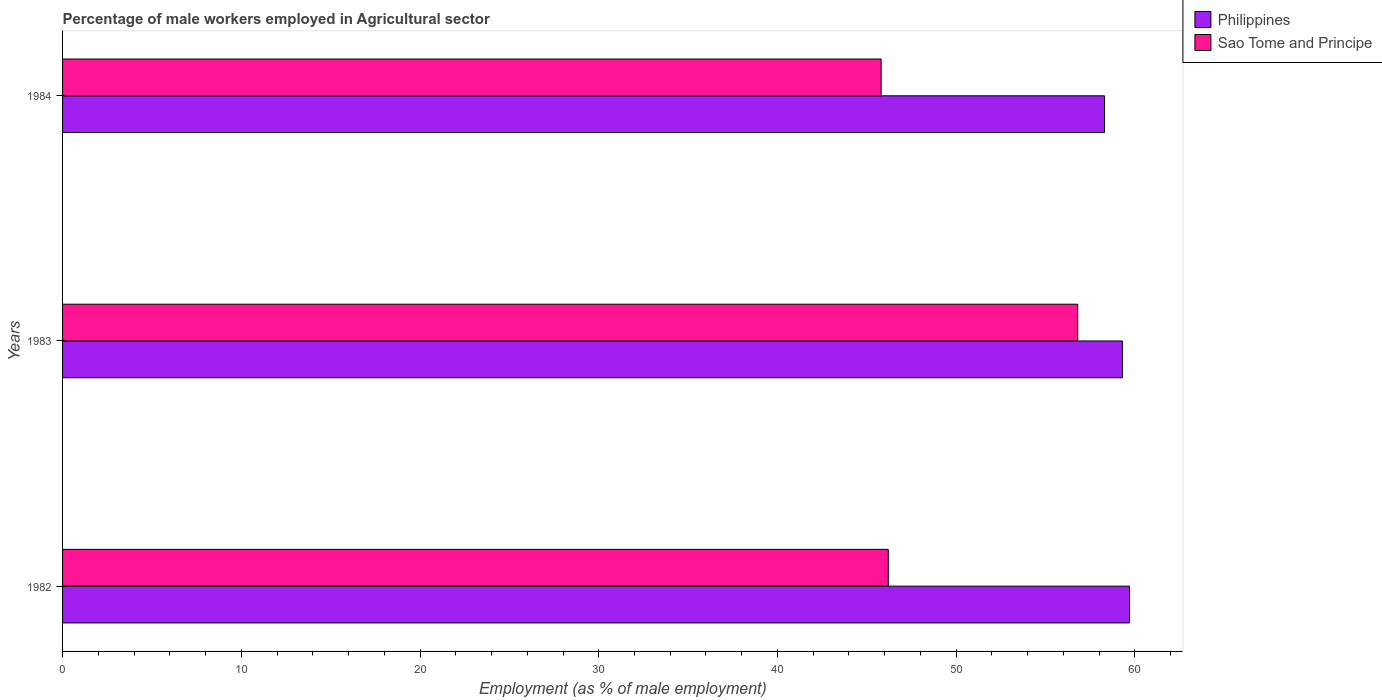How many groups of bars are there?
Make the answer very short. 3. What is the label of the 2nd group of bars from the top?
Your answer should be compact. 1983. What is the percentage of male workers employed in Agricultural sector in Philippines in 1982?
Keep it short and to the point. 59.7. Across all years, what is the maximum percentage of male workers employed in Agricultural sector in Philippines?
Offer a terse response. 59.7. Across all years, what is the minimum percentage of male workers employed in Agricultural sector in Sao Tome and Principe?
Your answer should be compact. 45.8. What is the total percentage of male workers employed in Agricultural sector in Sao Tome and Principe in the graph?
Provide a succinct answer. 148.8. What is the difference between the percentage of male workers employed in Agricultural sector in Philippines in 1982 and that in 1984?
Your answer should be very brief. 1.4. What is the difference between the percentage of male workers employed in Agricultural sector in Philippines in 1983 and the percentage of male workers employed in Agricultural sector in Sao Tome and Principe in 1984?
Keep it short and to the point. 13.5. What is the average percentage of male workers employed in Agricultural sector in Philippines per year?
Make the answer very short. 59.1. In how many years, is the percentage of male workers employed in Agricultural sector in Philippines greater than 28 %?
Provide a succinct answer. 3. What is the ratio of the percentage of male workers employed in Agricultural sector in Philippines in 1983 to that in 1984?
Offer a terse response. 1.02. Is the percentage of male workers employed in Agricultural sector in Philippines in 1983 less than that in 1984?
Your answer should be compact. No. Is the difference between the percentage of male workers employed in Agricultural sector in Sao Tome and Principe in 1982 and 1984 greater than the difference between the percentage of male workers employed in Agricultural sector in Philippines in 1982 and 1984?
Your answer should be very brief. No. What is the difference between the highest and the second highest percentage of male workers employed in Agricultural sector in Sao Tome and Principe?
Your answer should be very brief. 10.6. What is the difference between the highest and the lowest percentage of male workers employed in Agricultural sector in Philippines?
Offer a terse response. 1.4. Is the sum of the percentage of male workers employed in Agricultural sector in Sao Tome and Principe in 1982 and 1983 greater than the maximum percentage of male workers employed in Agricultural sector in Philippines across all years?
Keep it short and to the point. Yes. What does the 1st bar from the top in 1984 represents?
Offer a terse response. Sao Tome and Principe. What does the 2nd bar from the bottom in 1982 represents?
Your answer should be very brief. Sao Tome and Principe. How many bars are there?
Provide a short and direct response. 6. What is the difference between two consecutive major ticks on the X-axis?
Offer a terse response. 10. Where does the legend appear in the graph?
Provide a short and direct response. Top right. How are the legend labels stacked?
Keep it short and to the point. Vertical. What is the title of the graph?
Your answer should be compact. Percentage of male workers employed in Agricultural sector. What is the label or title of the X-axis?
Your answer should be very brief. Employment (as % of male employment). What is the label or title of the Y-axis?
Provide a short and direct response. Years. What is the Employment (as % of male employment) of Philippines in 1982?
Give a very brief answer. 59.7. What is the Employment (as % of male employment) in Sao Tome and Principe in 1982?
Give a very brief answer. 46.2. What is the Employment (as % of male employment) of Philippines in 1983?
Keep it short and to the point. 59.3. What is the Employment (as % of male employment) of Sao Tome and Principe in 1983?
Keep it short and to the point. 56.8. What is the Employment (as % of male employment) in Philippines in 1984?
Make the answer very short. 58.3. What is the Employment (as % of male employment) of Sao Tome and Principe in 1984?
Provide a succinct answer. 45.8. Across all years, what is the maximum Employment (as % of male employment) in Philippines?
Your response must be concise. 59.7. Across all years, what is the maximum Employment (as % of male employment) in Sao Tome and Principe?
Give a very brief answer. 56.8. Across all years, what is the minimum Employment (as % of male employment) of Philippines?
Make the answer very short. 58.3. Across all years, what is the minimum Employment (as % of male employment) of Sao Tome and Principe?
Your answer should be very brief. 45.8. What is the total Employment (as % of male employment) of Philippines in the graph?
Offer a terse response. 177.3. What is the total Employment (as % of male employment) of Sao Tome and Principe in the graph?
Ensure brevity in your answer.  148.8. What is the difference between the Employment (as % of male employment) in Philippines in 1982 and that in 1983?
Make the answer very short. 0.4. What is the difference between the Employment (as % of male employment) in Sao Tome and Principe in 1983 and that in 1984?
Offer a very short reply. 11. What is the difference between the Employment (as % of male employment) of Philippines in 1983 and the Employment (as % of male employment) of Sao Tome and Principe in 1984?
Provide a short and direct response. 13.5. What is the average Employment (as % of male employment) in Philippines per year?
Give a very brief answer. 59.1. What is the average Employment (as % of male employment) of Sao Tome and Principe per year?
Your response must be concise. 49.6. In the year 1983, what is the difference between the Employment (as % of male employment) of Philippines and Employment (as % of male employment) of Sao Tome and Principe?
Your answer should be very brief. 2.5. What is the ratio of the Employment (as % of male employment) of Sao Tome and Principe in 1982 to that in 1983?
Offer a very short reply. 0.81. What is the ratio of the Employment (as % of male employment) of Sao Tome and Principe in 1982 to that in 1984?
Offer a terse response. 1.01. What is the ratio of the Employment (as % of male employment) of Philippines in 1983 to that in 1984?
Your response must be concise. 1.02. What is the ratio of the Employment (as % of male employment) in Sao Tome and Principe in 1983 to that in 1984?
Make the answer very short. 1.24. What is the difference between the highest and the lowest Employment (as % of male employment) of Philippines?
Your answer should be compact. 1.4. What is the difference between the highest and the lowest Employment (as % of male employment) in Sao Tome and Principe?
Provide a succinct answer. 11. 